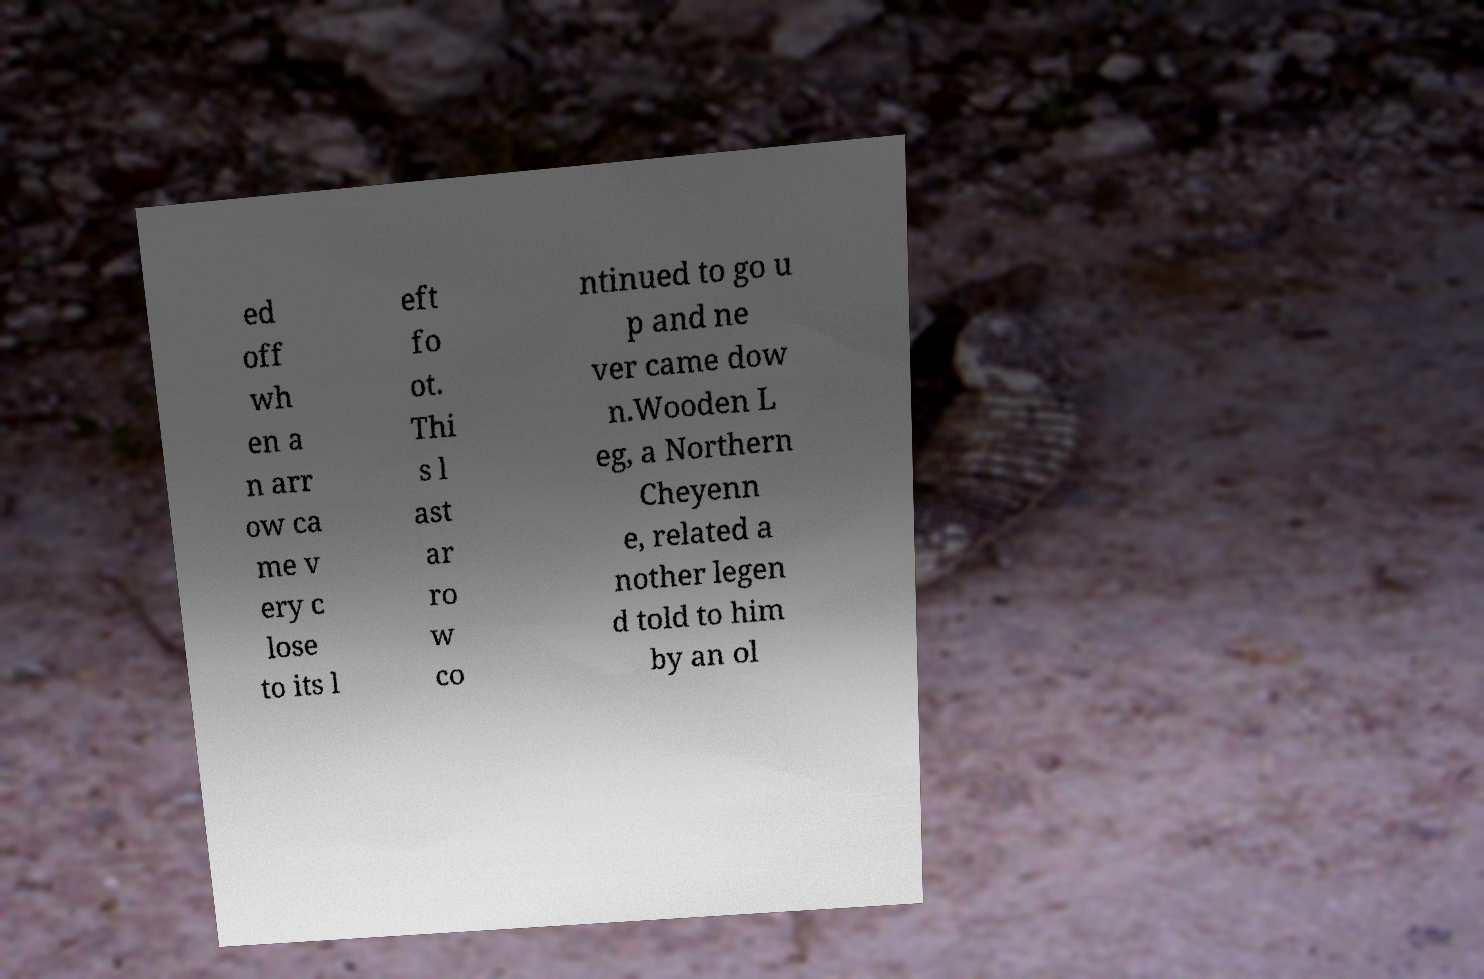For documentation purposes, I need the text within this image transcribed. Could you provide that? ed off wh en a n arr ow ca me v ery c lose to its l eft fo ot. Thi s l ast ar ro w co ntinued to go u p and ne ver came dow n.Wooden L eg, a Northern Cheyenn e, related a nother legen d told to him by an ol 